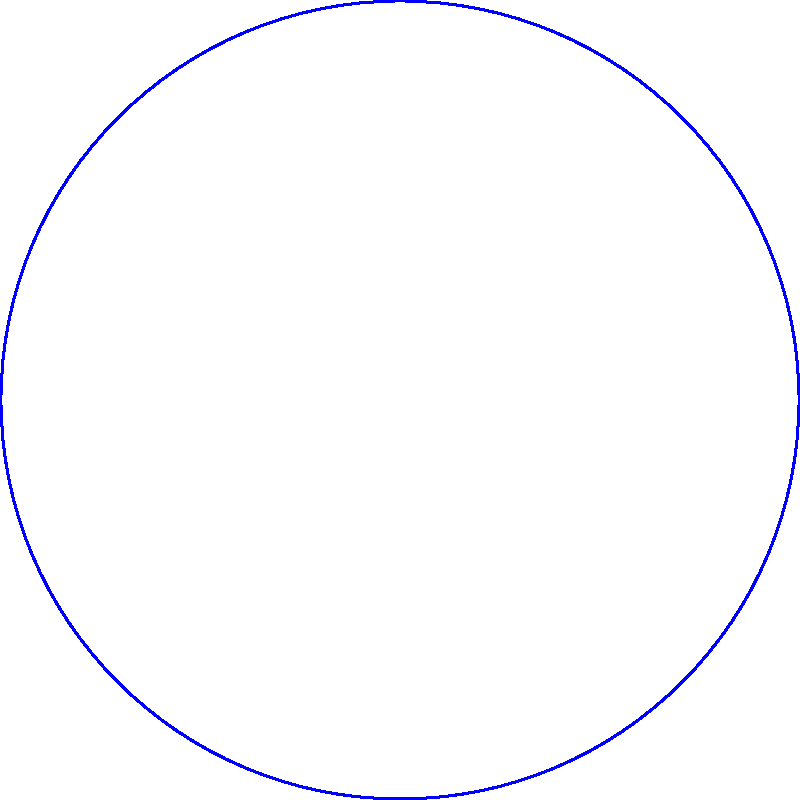As a traditional florist, you're asked to create a circular floral display for a classic wedding centerpiece. The display should have 8 evenly spaced roses around the circumference. Using polar coordinates, what angle (in degrees) should separate each rose to achieve this even spacing? To determine the angle between each rose in the circular display, we can follow these steps:

1. Recall that a full circle contains 360°.

2. We need to divide the circle into 8 equal parts, as we want 8 evenly spaced roses.

3. To calculate the angle between each rose, we divide the total degrees in a circle by the number of roses:

   $$\text{Angle between roses} = \frac{\text{Total degrees in a circle}}{\text{Number of roses}}$$

   $$\text{Angle between roses} = \frac{360°}{8}$$

4. Perform the division:

   $$\text{Angle between roses} = 45°$$

This means that each rose should be placed at intervals of 45° around the circle to achieve even spacing.

In polar coordinates, the first rose could be placed at $(r, 0°)$, the second at $(r, 45°)$, the third at $(r, 90°)$, and so on, where $r$ is the radius of the circular display.
Answer: 45° 